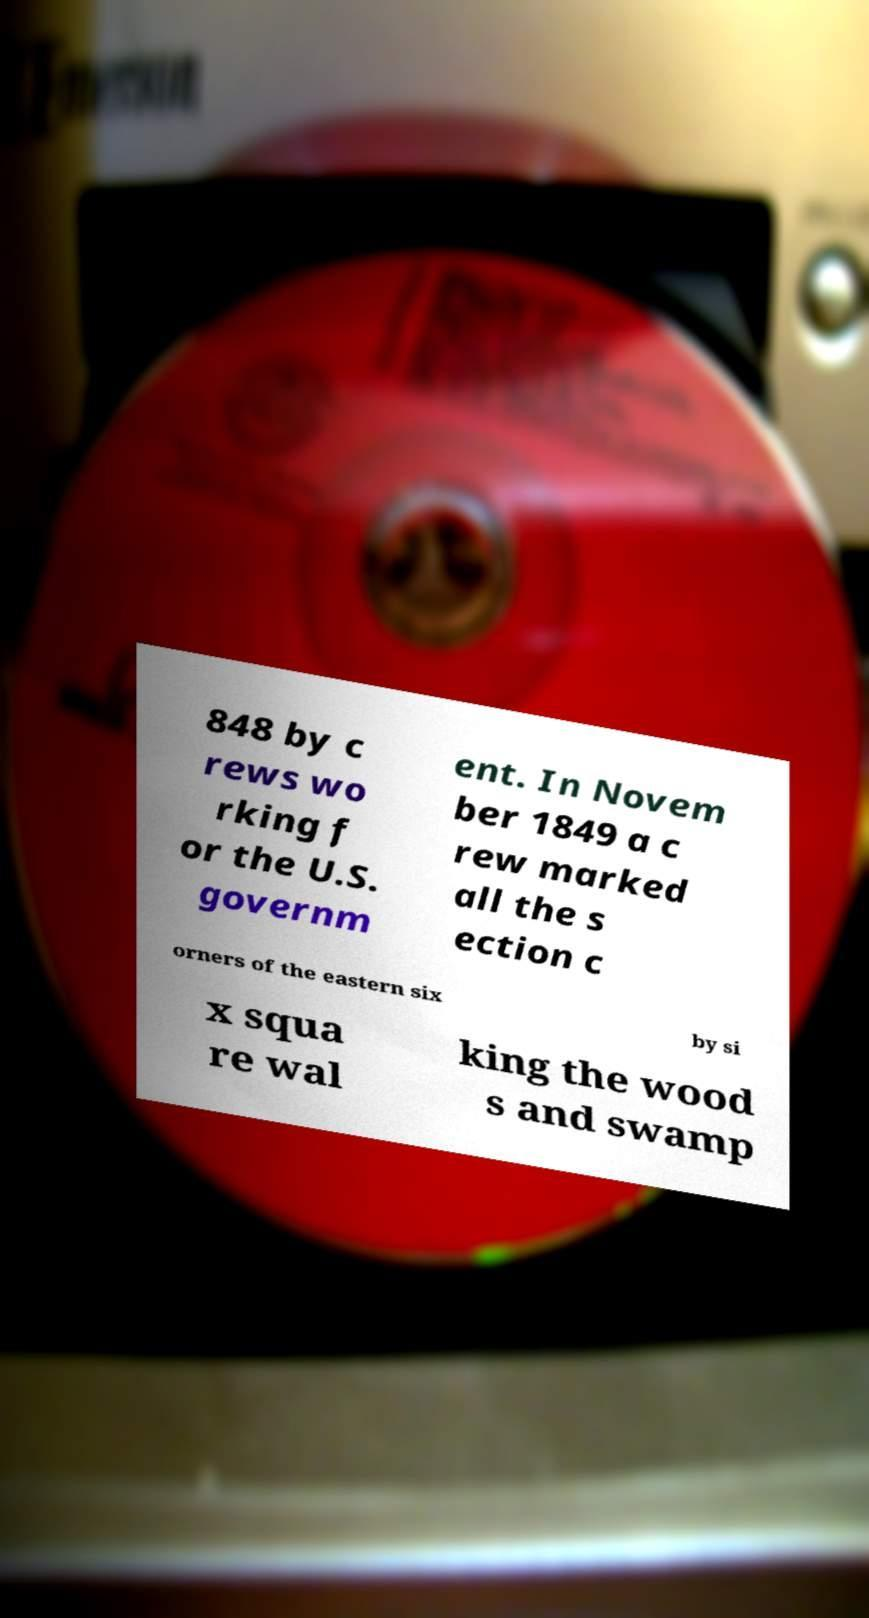Please read and relay the text visible in this image. What does it say? 848 by c rews wo rking f or the U.S. governm ent. In Novem ber 1849 a c rew marked all the s ection c orners of the eastern six by si x squa re wal king the wood s and swamp 